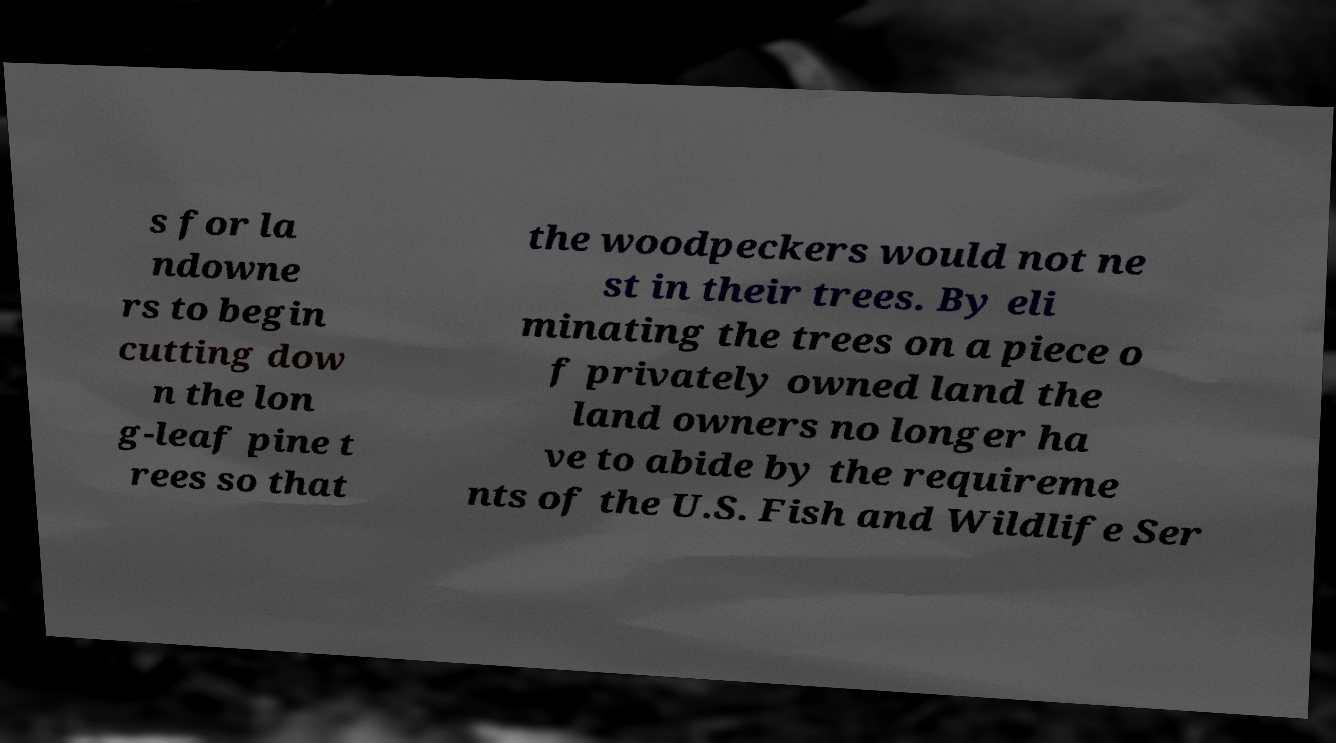Could you assist in decoding the text presented in this image and type it out clearly? s for la ndowne rs to begin cutting dow n the lon g-leaf pine t rees so that the woodpeckers would not ne st in their trees. By eli minating the trees on a piece o f privately owned land the land owners no longer ha ve to abide by the requireme nts of the U.S. Fish and Wildlife Ser 